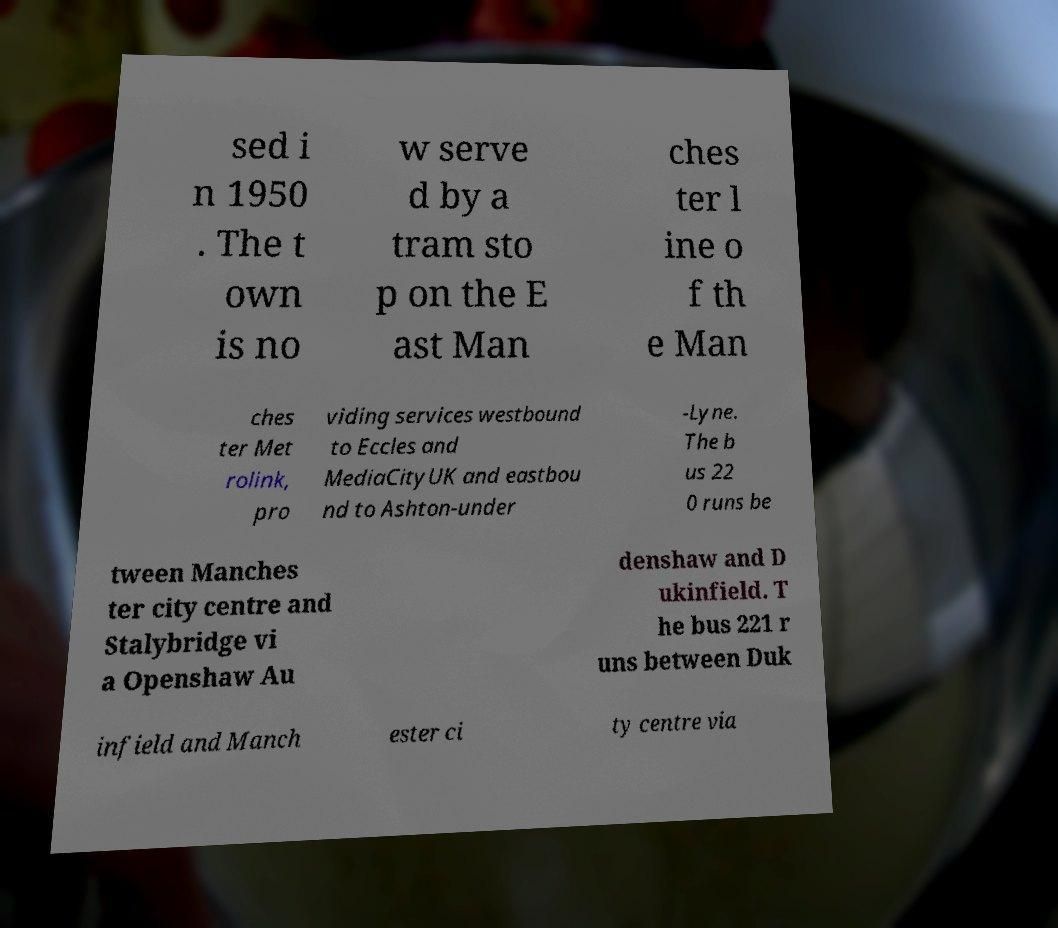Could you assist in decoding the text presented in this image and type it out clearly? sed i n 1950 . The t own is no w serve d by a tram sto p on the E ast Man ches ter l ine o f th e Man ches ter Met rolink, pro viding services westbound to Eccles and MediaCityUK and eastbou nd to Ashton-under -Lyne. The b us 22 0 runs be tween Manches ter city centre and Stalybridge vi a Openshaw Au denshaw and D ukinfield. T he bus 221 r uns between Duk infield and Manch ester ci ty centre via 